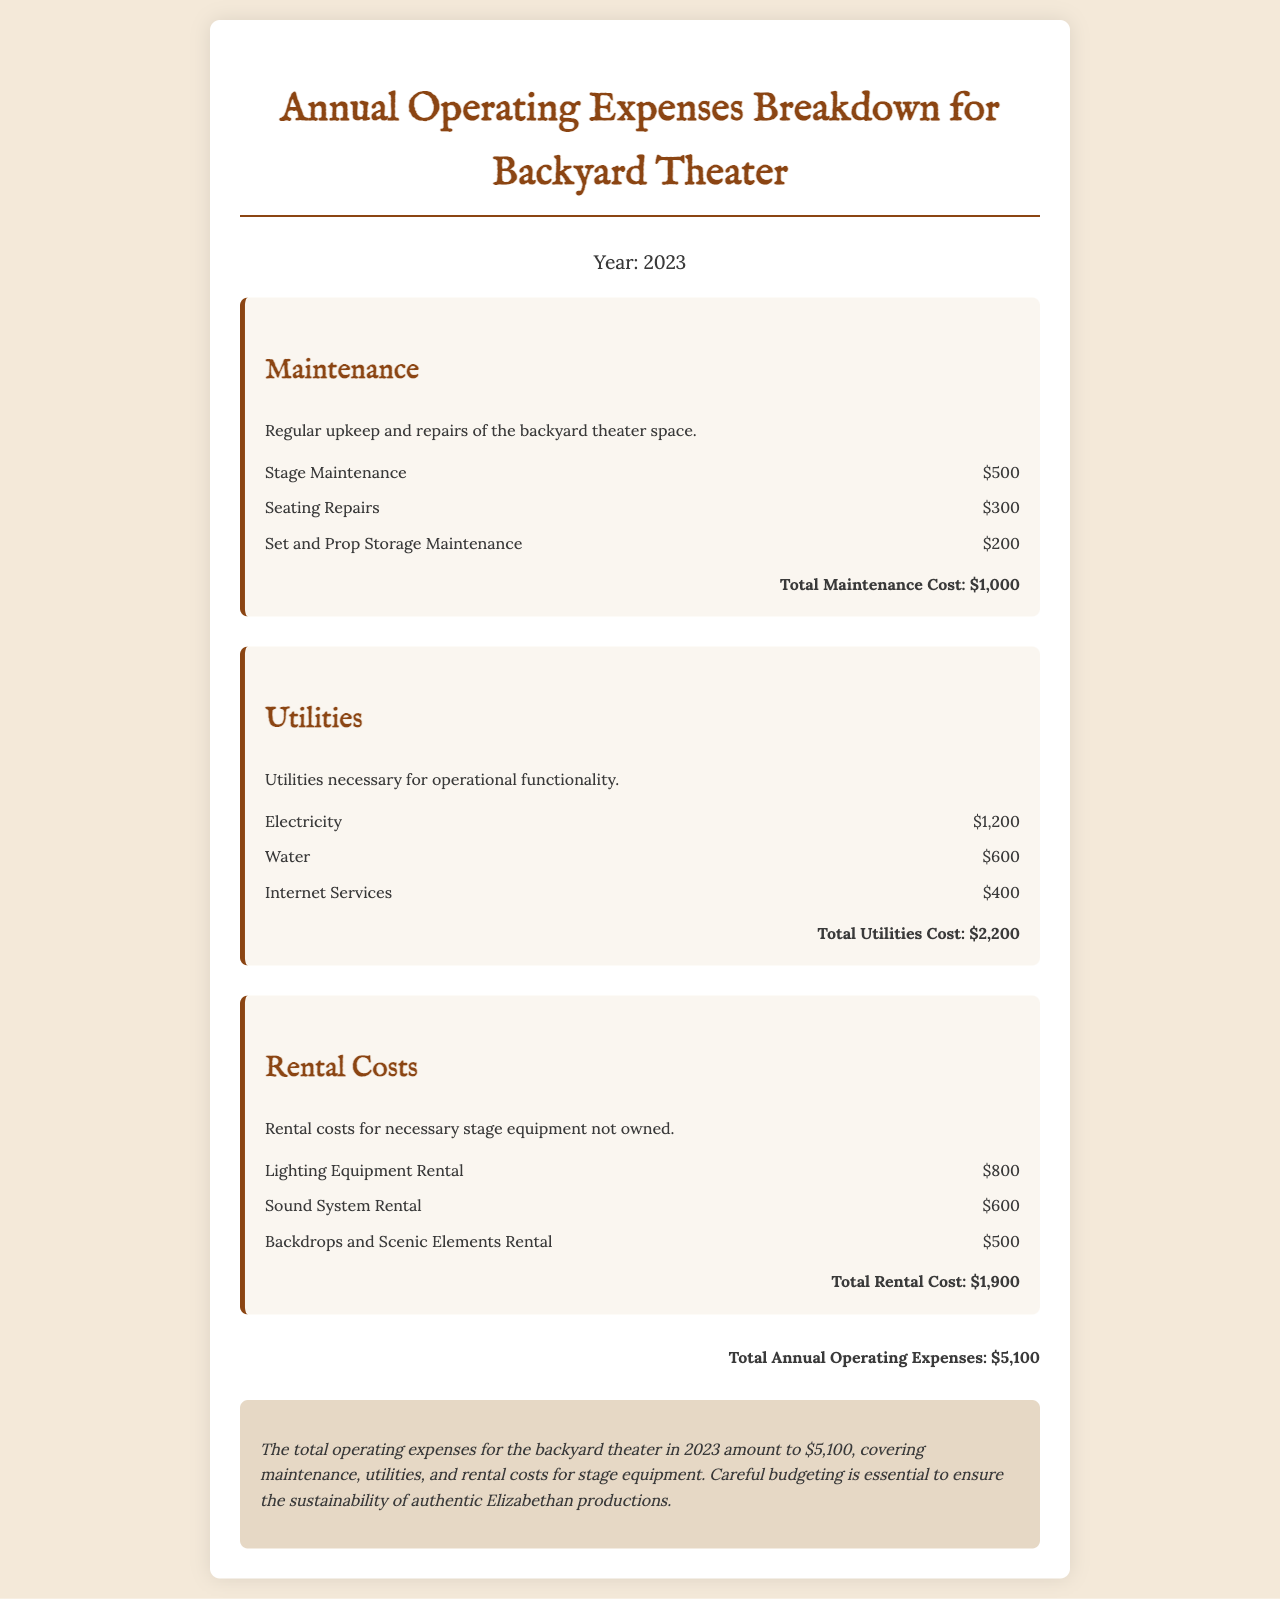What is the maintenance cost for stage maintenance? The document states the cost for stage maintenance is $500.
Answer: $500 What is the total cost of utilities? The total cost of utilities is summarized in the document as $2,200.
Answer: $2,200 How much is spent on seating repairs? The document lists seating repairs as costing $300.
Answer: $300 What is the total rental cost for stage equipment? The total rental cost appears in the document as $1,900.
Answer: $1,900 What is the overall total of annual operating expenses? The total annual operating expenses calculated from all sections is $5,100.
Answer: $5,100 How many expense sections are in the report? The document contains three expense sections: Maintenance, Utilities, and Rental Costs.
Answer: Three What utilities are mentioned in the document? The documented utilities include Electricity, Water, and Internet Services.
Answer: Electricity, Water, Internet Services Which rental equipment has the highest cost? The document indicates that Lighting Equipment Rental has the highest cost at $800.
Answer: Lighting Equipment Rental 